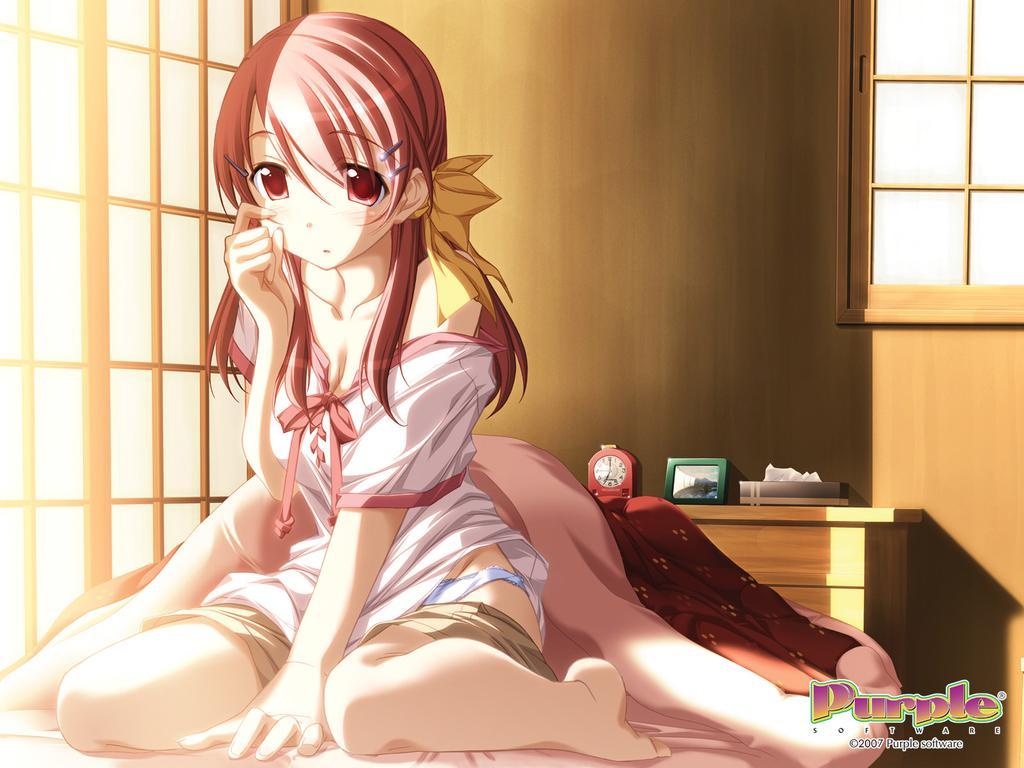How would you summarize this image in a sentence or two? In this picture I can observe cartoon image of a woman sitting on the bed. Behind the bed there is a desk on which I can observe an alarm. On the left side there are windows. In the background there is wall which is in brown color. 